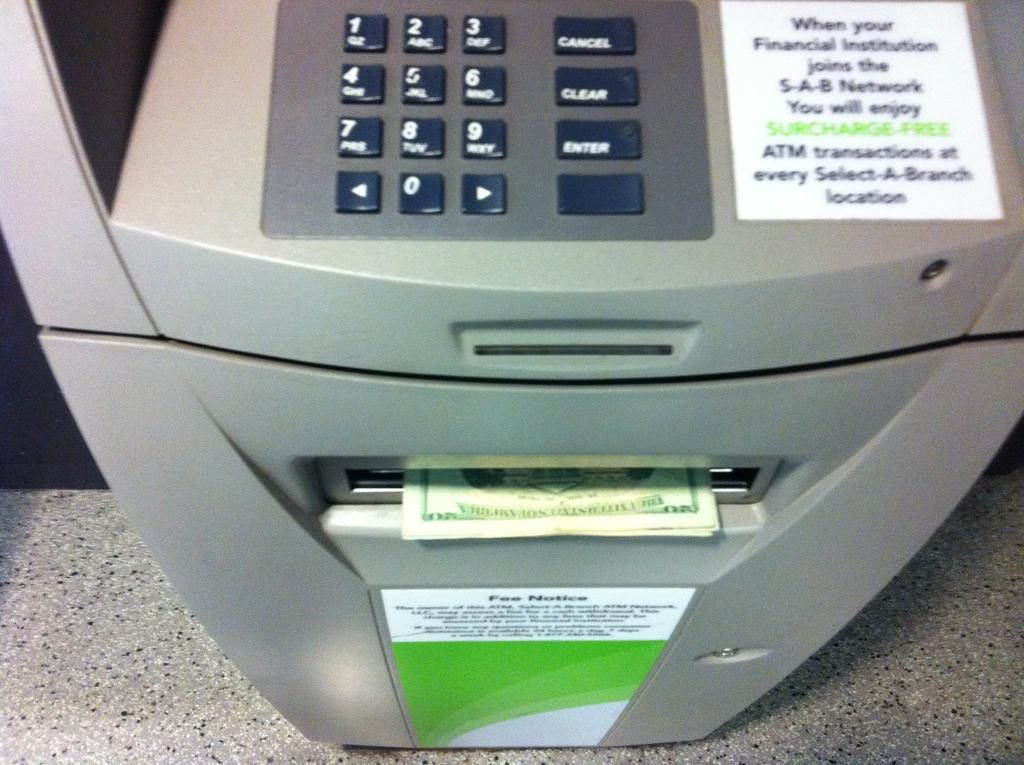<image>
Summarize the visual content of the image. A ATM machine with $20 dollar bill dispensed 